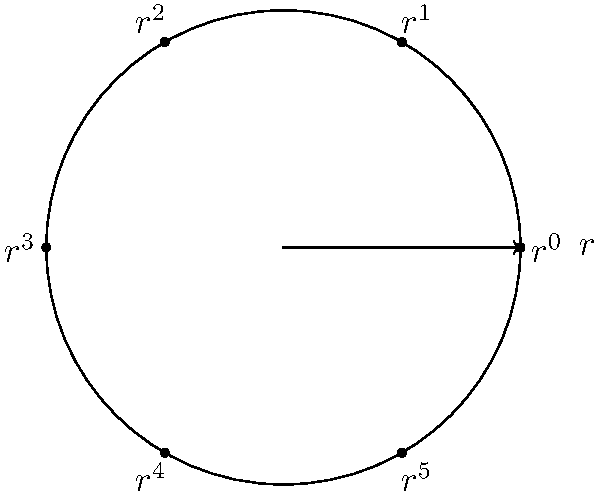In the context of ensuring software compliance with regulatory requirements, consider the cyclic group $C_6$ of order 6, represented by a hexagon diagram. Each vertex of the hexagon represents an element of the group, with $r$ denoting the generator of the group. How many elements in this group have order 2, and what is their significance in terms of compliance checks? To answer this question, let's analyze the cyclic group $C_6$ step-by-step:

1) The elements of $C_6$ are $\{e, r, r^2, r^3, r^4, r^5\}$, where $e$ is the identity element and $r$ is the generator.

2) To find elements of order 2, we need to identify elements $x$ such that $x^2 = e$ (identity), but $x \neq e$.

3) Let's check each element:
   - $(r^1)^2 = r^2 \neq e$
   - $(r^2)^2 = r^4 \neq e$
   - $(r^3)^2 = r^6 = e$ (since $r^6 = e$ in $C_6$)
   - $(r^4)^2 = r^8 = r^2 \neq e$
   - $(r^5)^2 = r^{10} = r^4 \neq e$

4) We find that only $r^3$ has order 2.

5) In terms of compliance checks, elements of order 2 can represent binary states or toggle operations in software systems. For example:
   - Compliance/Non-compliance status
   - Enabled/Disabled features
   - Approved/Rejected states for regulatory submissions

6) Having only one element of order 2 suggests that the system has a unique binary operation or state that returns to the initial condition after being applied twice. This could be crucial for implementing reversible processes or toggle switches in compliance-related software features.
Answer: 1 element (significance: represents unique binary state/operation in compliance systems) 